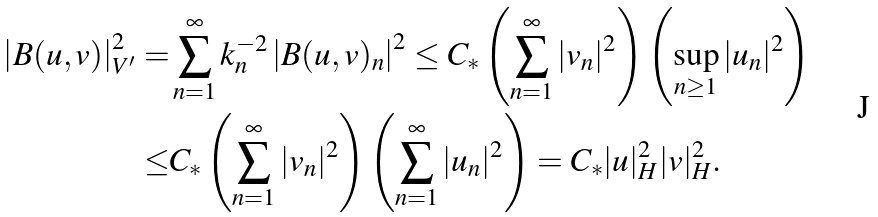<formula> <loc_0><loc_0><loc_500><loc_500>\left | B ( u , v ) \right | ^ { 2 } _ { V ^ { \prime } } = & \sum _ { n = 1 } ^ { \infty } k _ { n } ^ { - 2 } \left | B ( u , v ) _ { n } \right | ^ { 2 } \leq C _ { * } \left ( \sum _ { n = 1 } ^ { \infty } | { v } _ { n } | ^ { 2 } \right ) \left ( \sup _ { n \geq 1 } | { u } _ { n } | ^ { 2 } \right ) \\ \leq & C _ { * } \left ( \sum _ { n = 1 } ^ { \infty } | v _ { n } | ^ { 2 } \right ) \left ( \sum _ { n = 1 } ^ { \infty } | u _ { n } | ^ { 2 } \right ) = C _ { * } | u | ^ { 2 } _ { H } | v | ^ { 2 } _ { H } .</formula> 